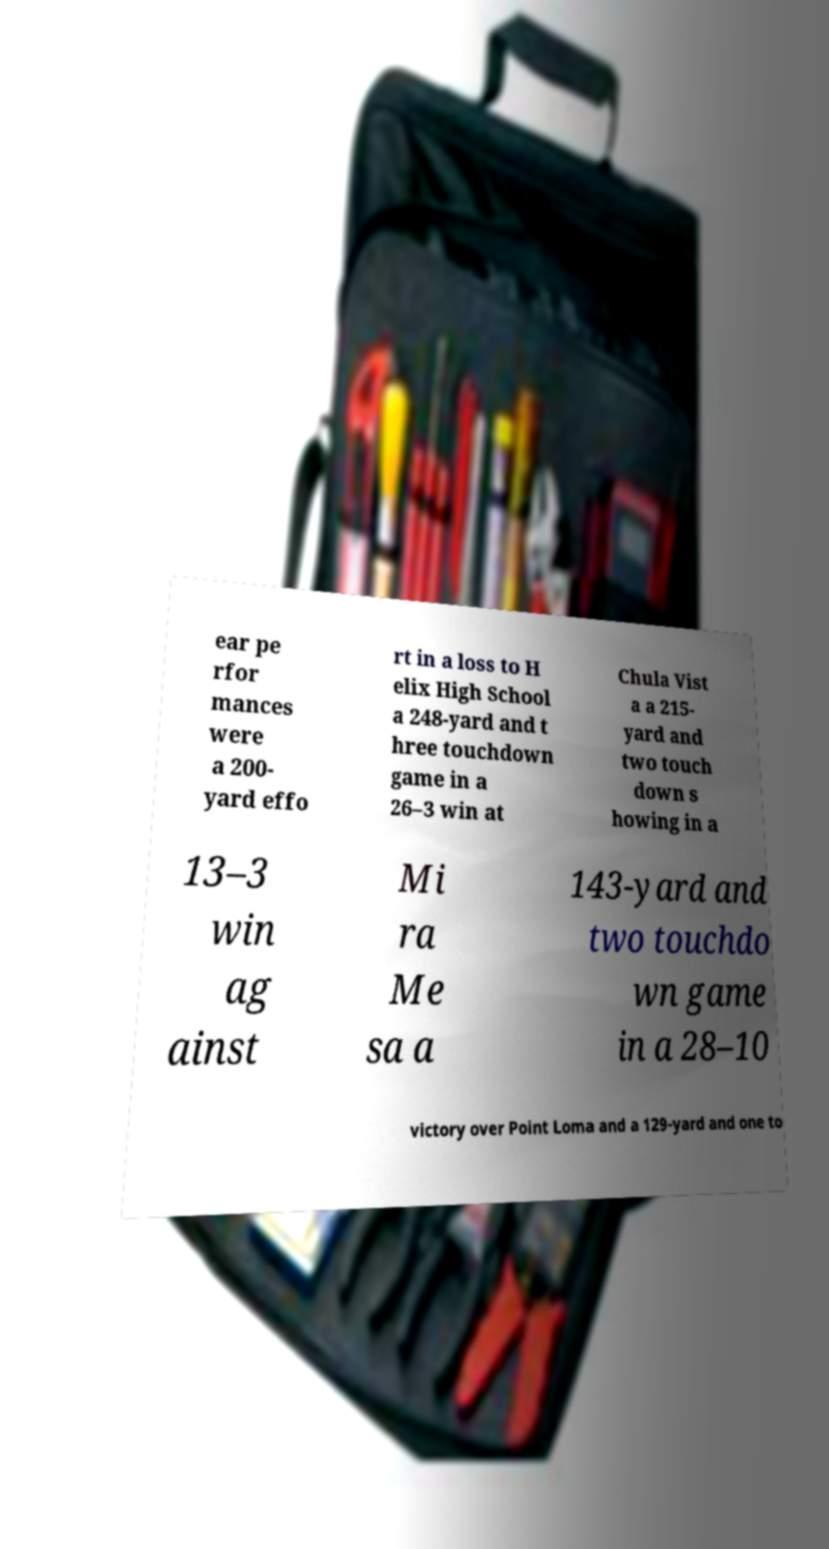There's text embedded in this image that I need extracted. Can you transcribe it verbatim? ear pe rfor mances were a 200- yard effo rt in a loss to H elix High School a 248-yard and t hree touchdown game in a 26–3 win at Chula Vist a a 215- yard and two touch down s howing in a 13–3 win ag ainst Mi ra Me sa a 143-yard and two touchdo wn game in a 28–10 victory over Point Loma and a 129-yard and one to 